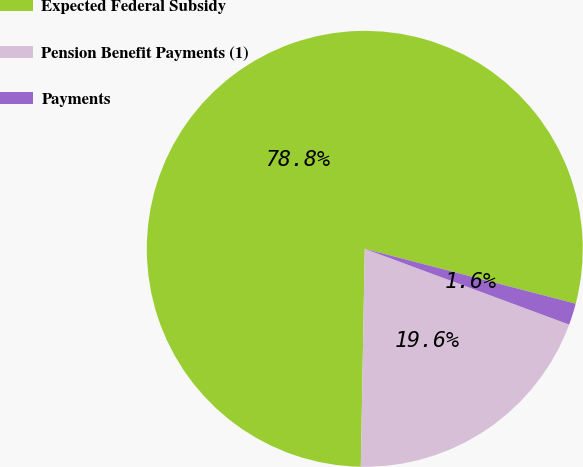<chart> <loc_0><loc_0><loc_500><loc_500><pie_chart><fcel>Expected Federal Subsidy<fcel>Pension Benefit Payments (1)<fcel>Payments<nl><fcel>78.76%<fcel>19.64%<fcel>1.6%<nl></chart> 